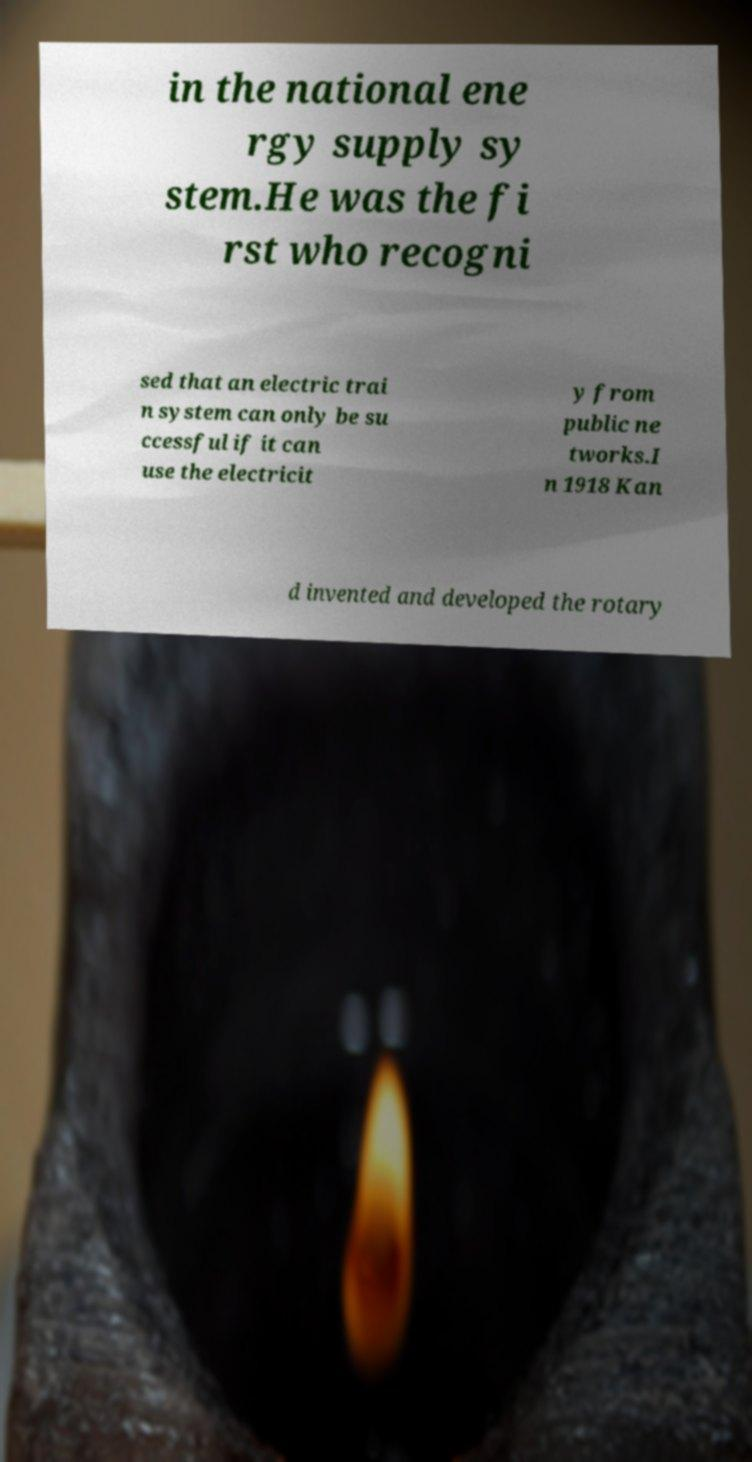There's text embedded in this image that I need extracted. Can you transcribe it verbatim? in the national ene rgy supply sy stem.He was the fi rst who recogni sed that an electric trai n system can only be su ccessful if it can use the electricit y from public ne tworks.I n 1918 Kan d invented and developed the rotary 